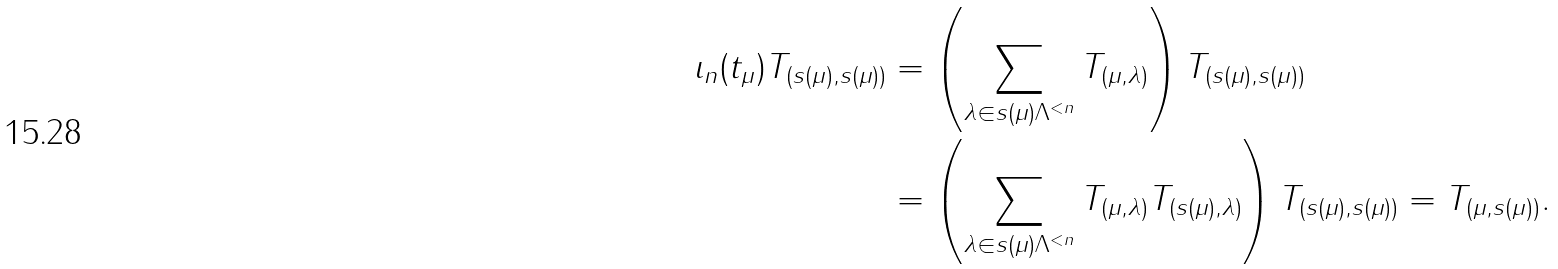Convert formula to latex. <formula><loc_0><loc_0><loc_500><loc_500>\iota _ { n } ( t _ { \mu } ) T _ { ( s ( \mu ) , s ( \mu ) ) } & = \left ( \sum _ { \lambda \in s ( \mu ) \Lambda ^ { < n } } T _ { ( \mu , \lambda ) } \right ) T _ { ( s ( \mu ) , s ( \mu ) ) } \\ & = \left ( \sum _ { \lambda \in s ( \mu ) \Lambda ^ { < n } } T _ { ( \mu , \lambda ) } T _ { ( s ( \mu ) , \lambda ) } \right ) T _ { ( s ( \mu ) , s ( \mu ) ) } = T _ { ( \mu , s ( \mu ) ) } .</formula> 